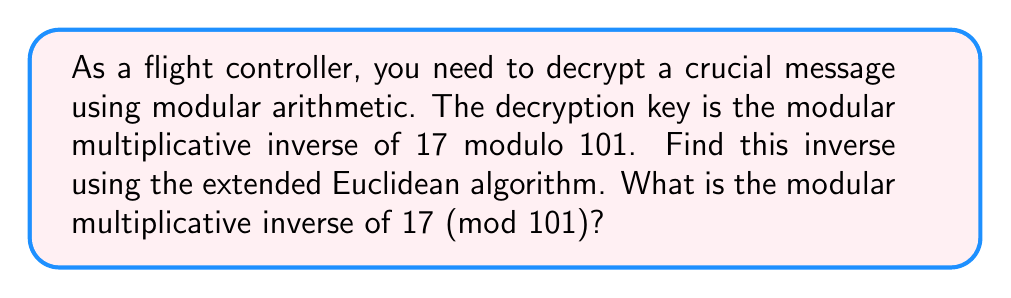Can you solve this math problem? Let's use the extended Euclidean algorithm to find the modular multiplicative inverse of 17 modulo 101.

We start by setting up the initial values:
$a = 101$, $b = 17$

We'll use these equations:
$ax + by = \gcd(a,b)$
$101x + 17y = 1$ (since we're looking for the inverse, we want the gcd to be 1)

Now, let's apply the algorithm:

1) $101 = 5 \times 17 + 16$
   $16 = 101 - 5 \times 17$

2) $17 = 1 \times 16 + 1$
   $1 = 17 - 1 \times 16$

3) Substituting the expression for 16 from step 1 into step 2:
   $1 = 17 - 1 \times (101 - 5 \times 17)$
   $1 = 17 - 101 + 5 \times 17$
   $1 = 6 \times 17 - 101$

4) Rearranging to match our target equation:
   $1 = 6 \times 17 - 1 \times 101$
   $101 \times (-1) + 17 \times 6 = 1$

Therefore, $x = -1$ and $y = 6$

The modular multiplicative inverse of 17 (mod 101) is 6, because:
$17 \times 6 \equiv 1 \pmod{101}$

We can verify:
$17 \times 6 = 102 \equiv 1 \pmod{101}$

Note that we could also express the answer as 95, since $6 \equiv 95 \pmod{101}$, and both work as the modular multiplicative inverse.
Answer: The modular multiplicative inverse of 17 modulo 101 is 6 (or equivalently, 95). 